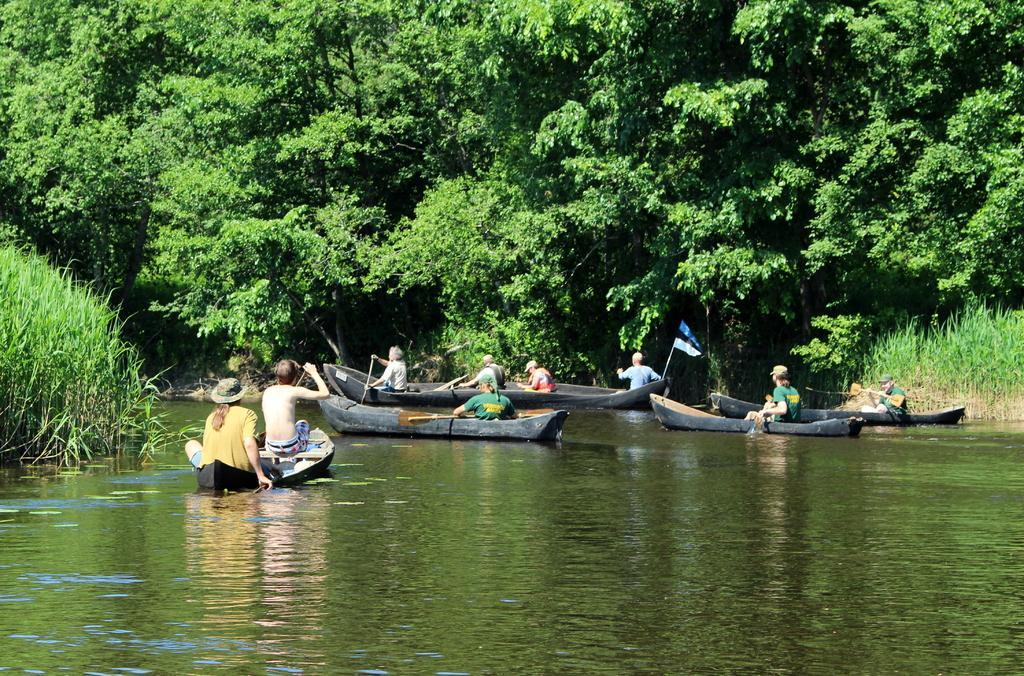Could you give a brief overview of what you see in this image? In this image I can see few persons sitting in the boat and the boat is on the water, background I can see trees in green color. 